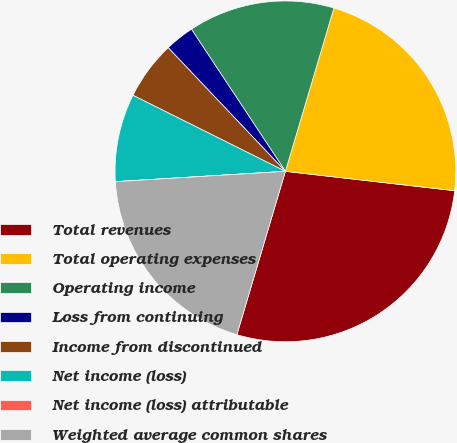<chart> <loc_0><loc_0><loc_500><loc_500><pie_chart><fcel>Total revenues<fcel>Total operating expenses<fcel>Operating income<fcel>Loss from continuing<fcel>Income from discontinued<fcel>Net income (loss)<fcel>Net income (loss) attributable<fcel>Weighted average common shares<nl><fcel>27.78%<fcel>22.22%<fcel>13.89%<fcel>2.78%<fcel>5.56%<fcel>8.33%<fcel>0.0%<fcel>19.44%<nl></chart> 